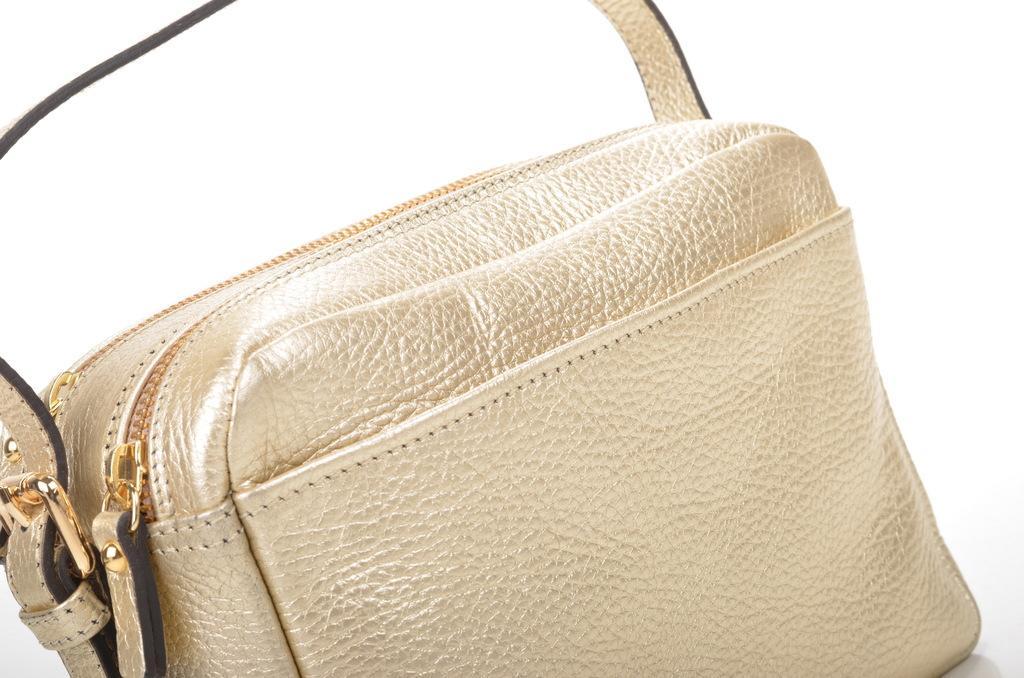Could you give a brief overview of what you see in this image? in this image i can see a golden color hand bag which has two zips and a strip. 